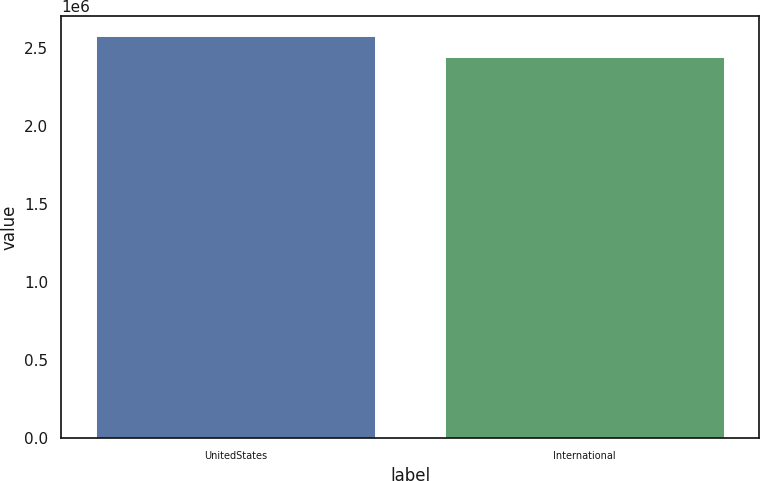<chart> <loc_0><loc_0><loc_500><loc_500><bar_chart><fcel>UnitedStates<fcel>International<nl><fcel>2.5757e+06<fcel>2.44413e+06<nl></chart> 